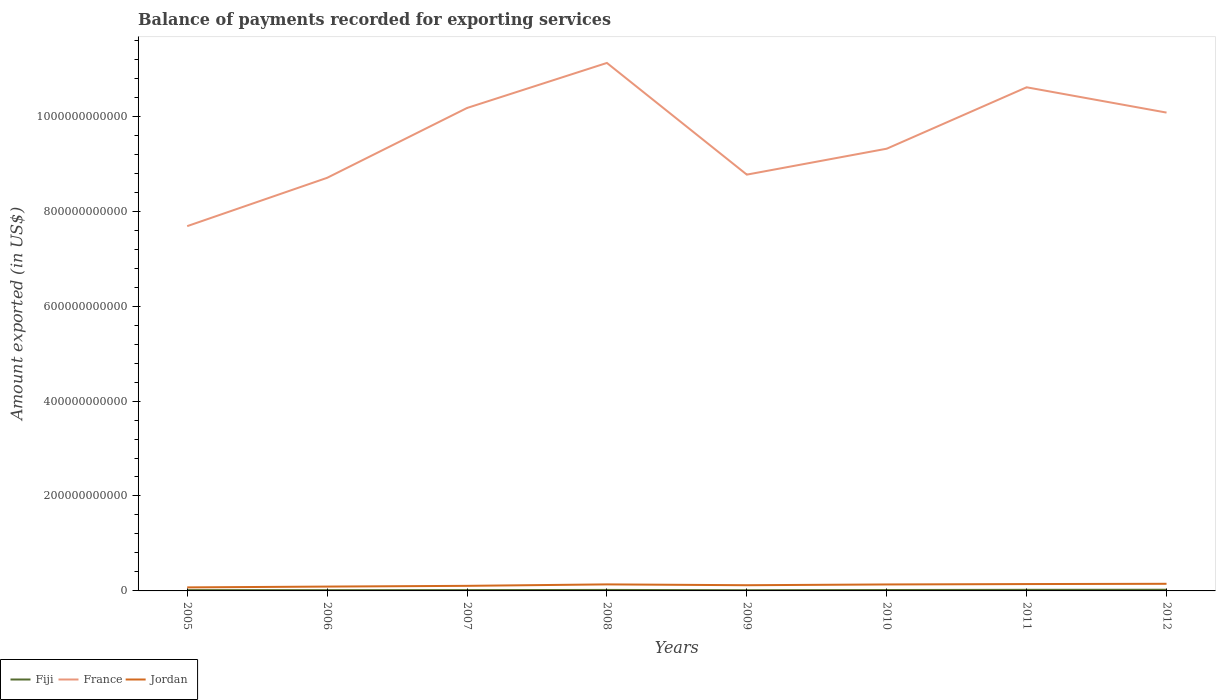How many different coloured lines are there?
Your response must be concise. 3. Does the line corresponding to Fiji intersect with the line corresponding to France?
Your response must be concise. No. Is the number of lines equal to the number of legend labels?
Keep it short and to the point. Yes. Across all years, what is the maximum amount exported in Fiji?
Offer a terse response. 1.48e+09. What is the total amount exported in France in the graph?
Ensure brevity in your answer.  -9.49e+1. What is the difference between the highest and the second highest amount exported in France?
Provide a succinct answer. 3.44e+11. How many lines are there?
Offer a terse response. 3. How many years are there in the graph?
Your answer should be very brief. 8. What is the difference between two consecutive major ticks on the Y-axis?
Give a very brief answer. 2.00e+11. Are the values on the major ticks of Y-axis written in scientific E-notation?
Your response must be concise. No. Does the graph contain any zero values?
Ensure brevity in your answer.  No. Does the graph contain grids?
Offer a terse response. No. Where does the legend appear in the graph?
Your response must be concise. Bottom left. How many legend labels are there?
Your answer should be very brief. 3. What is the title of the graph?
Provide a short and direct response. Balance of payments recorded for exporting services. What is the label or title of the Y-axis?
Make the answer very short. Amount exported (in US$). What is the Amount exported (in US$) in Fiji in 2005?
Make the answer very short. 1.69e+09. What is the Amount exported (in US$) of France in 2005?
Ensure brevity in your answer.  7.68e+11. What is the Amount exported (in US$) in Jordan in 2005?
Provide a succinct answer. 7.43e+09. What is the Amount exported (in US$) in Fiji in 2006?
Give a very brief answer. 1.61e+09. What is the Amount exported (in US$) in France in 2006?
Your response must be concise. 8.70e+11. What is the Amount exported (in US$) of Jordan in 2006?
Offer a terse response. 9.14e+09. What is the Amount exported (in US$) of Fiji in 2007?
Make the answer very short. 1.72e+09. What is the Amount exported (in US$) in France in 2007?
Your response must be concise. 1.02e+12. What is the Amount exported (in US$) in Jordan in 2007?
Provide a succinct answer. 1.07e+1. What is the Amount exported (in US$) in Fiji in 2008?
Offer a very short reply. 2.09e+09. What is the Amount exported (in US$) of France in 2008?
Your response must be concise. 1.11e+12. What is the Amount exported (in US$) in Jordan in 2008?
Provide a succinct answer. 1.38e+1. What is the Amount exported (in US$) of Fiji in 2009?
Offer a terse response. 1.48e+09. What is the Amount exported (in US$) in France in 2009?
Your answer should be compact. 8.77e+11. What is the Amount exported (in US$) in Jordan in 2009?
Your answer should be compact. 1.20e+1. What is the Amount exported (in US$) of Fiji in 2010?
Ensure brevity in your answer.  1.90e+09. What is the Amount exported (in US$) in France in 2010?
Your response must be concise. 9.32e+11. What is the Amount exported (in US$) of Jordan in 2010?
Provide a short and direct response. 1.36e+1. What is the Amount exported (in US$) in Fiji in 2011?
Offer a very short reply. 2.33e+09. What is the Amount exported (in US$) of France in 2011?
Your answer should be compact. 1.06e+12. What is the Amount exported (in US$) of Jordan in 2011?
Provide a short and direct response. 1.45e+1. What is the Amount exported (in US$) in Fiji in 2012?
Your response must be concise. 2.51e+09. What is the Amount exported (in US$) in France in 2012?
Your answer should be compact. 1.01e+12. What is the Amount exported (in US$) in Jordan in 2012?
Offer a terse response. 1.50e+1. Across all years, what is the maximum Amount exported (in US$) of Fiji?
Your response must be concise. 2.51e+09. Across all years, what is the maximum Amount exported (in US$) of France?
Provide a short and direct response. 1.11e+12. Across all years, what is the maximum Amount exported (in US$) in Jordan?
Your response must be concise. 1.50e+1. Across all years, what is the minimum Amount exported (in US$) in Fiji?
Offer a very short reply. 1.48e+09. Across all years, what is the minimum Amount exported (in US$) in France?
Make the answer very short. 7.68e+11. Across all years, what is the minimum Amount exported (in US$) of Jordan?
Provide a short and direct response. 7.43e+09. What is the total Amount exported (in US$) in Fiji in the graph?
Give a very brief answer. 1.53e+1. What is the total Amount exported (in US$) in France in the graph?
Your answer should be compact. 7.65e+12. What is the total Amount exported (in US$) in Jordan in the graph?
Offer a terse response. 9.61e+1. What is the difference between the Amount exported (in US$) in Fiji in 2005 and that in 2006?
Your answer should be very brief. 8.41e+07. What is the difference between the Amount exported (in US$) of France in 2005 and that in 2006?
Offer a terse response. -1.02e+11. What is the difference between the Amount exported (in US$) in Jordan in 2005 and that in 2006?
Your response must be concise. -1.72e+09. What is the difference between the Amount exported (in US$) of Fiji in 2005 and that in 2007?
Make the answer very short. -2.36e+07. What is the difference between the Amount exported (in US$) in France in 2005 and that in 2007?
Ensure brevity in your answer.  -2.49e+11. What is the difference between the Amount exported (in US$) of Jordan in 2005 and that in 2007?
Offer a terse response. -3.26e+09. What is the difference between the Amount exported (in US$) in Fiji in 2005 and that in 2008?
Ensure brevity in your answer.  -3.97e+08. What is the difference between the Amount exported (in US$) of France in 2005 and that in 2008?
Provide a succinct answer. -3.44e+11. What is the difference between the Amount exported (in US$) of Jordan in 2005 and that in 2008?
Ensure brevity in your answer.  -6.32e+09. What is the difference between the Amount exported (in US$) of Fiji in 2005 and that in 2009?
Your response must be concise. 2.10e+08. What is the difference between the Amount exported (in US$) of France in 2005 and that in 2009?
Offer a very short reply. -1.09e+11. What is the difference between the Amount exported (in US$) in Jordan in 2005 and that in 2009?
Your answer should be compact. -4.60e+09. What is the difference between the Amount exported (in US$) in Fiji in 2005 and that in 2010?
Keep it short and to the point. -2.05e+08. What is the difference between the Amount exported (in US$) of France in 2005 and that in 2010?
Your response must be concise. -1.63e+11. What is the difference between the Amount exported (in US$) of Jordan in 2005 and that in 2010?
Provide a succinct answer. -6.21e+09. What is the difference between the Amount exported (in US$) in Fiji in 2005 and that in 2011?
Your answer should be compact. -6.37e+08. What is the difference between the Amount exported (in US$) of France in 2005 and that in 2011?
Your answer should be compact. -2.93e+11. What is the difference between the Amount exported (in US$) in Jordan in 2005 and that in 2011?
Provide a succinct answer. -7.03e+09. What is the difference between the Amount exported (in US$) of Fiji in 2005 and that in 2012?
Offer a terse response. -8.17e+08. What is the difference between the Amount exported (in US$) of France in 2005 and that in 2012?
Offer a terse response. -2.39e+11. What is the difference between the Amount exported (in US$) in Jordan in 2005 and that in 2012?
Your response must be concise. -7.57e+09. What is the difference between the Amount exported (in US$) of Fiji in 2006 and that in 2007?
Provide a succinct answer. -1.08e+08. What is the difference between the Amount exported (in US$) of France in 2006 and that in 2007?
Provide a succinct answer. -1.47e+11. What is the difference between the Amount exported (in US$) of Jordan in 2006 and that in 2007?
Offer a very short reply. -1.54e+09. What is the difference between the Amount exported (in US$) of Fiji in 2006 and that in 2008?
Give a very brief answer. -4.81e+08. What is the difference between the Amount exported (in US$) in France in 2006 and that in 2008?
Offer a terse response. -2.42e+11. What is the difference between the Amount exported (in US$) of Jordan in 2006 and that in 2008?
Give a very brief answer. -4.61e+09. What is the difference between the Amount exported (in US$) in Fiji in 2006 and that in 2009?
Offer a terse response. 1.26e+08. What is the difference between the Amount exported (in US$) in France in 2006 and that in 2009?
Offer a terse response. -6.76e+09. What is the difference between the Amount exported (in US$) in Jordan in 2006 and that in 2009?
Ensure brevity in your answer.  -2.88e+09. What is the difference between the Amount exported (in US$) in Fiji in 2006 and that in 2010?
Provide a short and direct response. -2.89e+08. What is the difference between the Amount exported (in US$) in France in 2006 and that in 2010?
Provide a succinct answer. -6.14e+1. What is the difference between the Amount exported (in US$) of Jordan in 2006 and that in 2010?
Your answer should be very brief. -4.50e+09. What is the difference between the Amount exported (in US$) in Fiji in 2006 and that in 2011?
Your answer should be compact. -7.21e+08. What is the difference between the Amount exported (in US$) of France in 2006 and that in 2011?
Make the answer very short. -1.91e+11. What is the difference between the Amount exported (in US$) in Jordan in 2006 and that in 2011?
Your response must be concise. -5.31e+09. What is the difference between the Amount exported (in US$) of Fiji in 2006 and that in 2012?
Keep it short and to the point. -9.01e+08. What is the difference between the Amount exported (in US$) in France in 2006 and that in 2012?
Offer a very short reply. -1.37e+11. What is the difference between the Amount exported (in US$) in Jordan in 2006 and that in 2012?
Keep it short and to the point. -5.85e+09. What is the difference between the Amount exported (in US$) of Fiji in 2007 and that in 2008?
Your response must be concise. -3.73e+08. What is the difference between the Amount exported (in US$) of France in 2007 and that in 2008?
Offer a terse response. -9.49e+1. What is the difference between the Amount exported (in US$) of Jordan in 2007 and that in 2008?
Provide a succinct answer. -3.07e+09. What is the difference between the Amount exported (in US$) of Fiji in 2007 and that in 2009?
Your answer should be very brief. 2.34e+08. What is the difference between the Amount exported (in US$) in France in 2007 and that in 2009?
Offer a very short reply. 1.40e+11. What is the difference between the Amount exported (in US$) of Jordan in 2007 and that in 2009?
Offer a very short reply. -1.34e+09. What is the difference between the Amount exported (in US$) of Fiji in 2007 and that in 2010?
Provide a succinct answer. -1.82e+08. What is the difference between the Amount exported (in US$) of France in 2007 and that in 2010?
Provide a succinct answer. 8.58e+1. What is the difference between the Amount exported (in US$) of Jordan in 2007 and that in 2010?
Keep it short and to the point. -2.96e+09. What is the difference between the Amount exported (in US$) in Fiji in 2007 and that in 2011?
Keep it short and to the point. -6.14e+08. What is the difference between the Amount exported (in US$) in France in 2007 and that in 2011?
Offer a terse response. -4.36e+1. What is the difference between the Amount exported (in US$) of Jordan in 2007 and that in 2011?
Provide a short and direct response. -3.77e+09. What is the difference between the Amount exported (in US$) of Fiji in 2007 and that in 2012?
Your answer should be very brief. -7.94e+08. What is the difference between the Amount exported (in US$) in France in 2007 and that in 2012?
Ensure brevity in your answer.  9.70e+09. What is the difference between the Amount exported (in US$) of Jordan in 2007 and that in 2012?
Give a very brief answer. -4.31e+09. What is the difference between the Amount exported (in US$) in Fiji in 2008 and that in 2009?
Provide a short and direct response. 6.07e+08. What is the difference between the Amount exported (in US$) in France in 2008 and that in 2009?
Your answer should be compact. 2.35e+11. What is the difference between the Amount exported (in US$) in Jordan in 2008 and that in 2009?
Your answer should be compact. 1.73e+09. What is the difference between the Amount exported (in US$) of Fiji in 2008 and that in 2010?
Keep it short and to the point. 1.92e+08. What is the difference between the Amount exported (in US$) of France in 2008 and that in 2010?
Your answer should be compact. 1.81e+11. What is the difference between the Amount exported (in US$) in Jordan in 2008 and that in 2010?
Make the answer very short. 1.12e+08. What is the difference between the Amount exported (in US$) in Fiji in 2008 and that in 2011?
Offer a terse response. -2.40e+08. What is the difference between the Amount exported (in US$) of France in 2008 and that in 2011?
Keep it short and to the point. 5.13e+1. What is the difference between the Amount exported (in US$) in Jordan in 2008 and that in 2011?
Your response must be concise. -7.04e+08. What is the difference between the Amount exported (in US$) in Fiji in 2008 and that in 2012?
Your answer should be very brief. -4.21e+08. What is the difference between the Amount exported (in US$) of France in 2008 and that in 2012?
Provide a succinct answer. 1.05e+11. What is the difference between the Amount exported (in US$) of Jordan in 2008 and that in 2012?
Provide a succinct answer. -1.25e+09. What is the difference between the Amount exported (in US$) of Fiji in 2009 and that in 2010?
Provide a succinct answer. -4.15e+08. What is the difference between the Amount exported (in US$) in France in 2009 and that in 2010?
Your response must be concise. -5.46e+1. What is the difference between the Amount exported (in US$) of Jordan in 2009 and that in 2010?
Offer a terse response. -1.62e+09. What is the difference between the Amount exported (in US$) of Fiji in 2009 and that in 2011?
Your response must be concise. -8.47e+08. What is the difference between the Amount exported (in US$) in France in 2009 and that in 2011?
Give a very brief answer. -1.84e+11. What is the difference between the Amount exported (in US$) in Jordan in 2009 and that in 2011?
Your answer should be compact. -2.43e+09. What is the difference between the Amount exported (in US$) of Fiji in 2009 and that in 2012?
Give a very brief answer. -1.03e+09. What is the difference between the Amount exported (in US$) in France in 2009 and that in 2012?
Offer a terse response. -1.31e+11. What is the difference between the Amount exported (in US$) of Jordan in 2009 and that in 2012?
Make the answer very short. -2.97e+09. What is the difference between the Amount exported (in US$) of Fiji in 2010 and that in 2011?
Ensure brevity in your answer.  -4.32e+08. What is the difference between the Amount exported (in US$) in France in 2010 and that in 2011?
Make the answer very short. -1.29e+11. What is the difference between the Amount exported (in US$) in Jordan in 2010 and that in 2011?
Your answer should be compact. -8.15e+08. What is the difference between the Amount exported (in US$) in Fiji in 2010 and that in 2012?
Provide a short and direct response. -6.12e+08. What is the difference between the Amount exported (in US$) of France in 2010 and that in 2012?
Give a very brief answer. -7.61e+1. What is the difference between the Amount exported (in US$) of Jordan in 2010 and that in 2012?
Keep it short and to the point. -1.36e+09. What is the difference between the Amount exported (in US$) of Fiji in 2011 and that in 2012?
Offer a very short reply. -1.80e+08. What is the difference between the Amount exported (in US$) of France in 2011 and that in 2012?
Give a very brief answer. 5.33e+1. What is the difference between the Amount exported (in US$) in Jordan in 2011 and that in 2012?
Offer a terse response. -5.43e+08. What is the difference between the Amount exported (in US$) in Fiji in 2005 and the Amount exported (in US$) in France in 2006?
Your response must be concise. -8.69e+11. What is the difference between the Amount exported (in US$) in Fiji in 2005 and the Amount exported (in US$) in Jordan in 2006?
Keep it short and to the point. -7.45e+09. What is the difference between the Amount exported (in US$) in France in 2005 and the Amount exported (in US$) in Jordan in 2006?
Your response must be concise. 7.59e+11. What is the difference between the Amount exported (in US$) of Fiji in 2005 and the Amount exported (in US$) of France in 2007?
Make the answer very short. -1.02e+12. What is the difference between the Amount exported (in US$) of Fiji in 2005 and the Amount exported (in US$) of Jordan in 2007?
Ensure brevity in your answer.  -8.99e+09. What is the difference between the Amount exported (in US$) of France in 2005 and the Amount exported (in US$) of Jordan in 2007?
Your answer should be very brief. 7.58e+11. What is the difference between the Amount exported (in US$) in Fiji in 2005 and the Amount exported (in US$) in France in 2008?
Give a very brief answer. -1.11e+12. What is the difference between the Amount exported (in US$) in Fiji in 2005 and the Amount exported (in US$) in Jordan in 2008?
Offer a terse response. -1.21e+1. What is the difference between the Amount exported (in US$) in France in 2005 and the Amount exported (in US$) in Jordan in 2008?
Your answer should be compact. 7.55e+11. What is the difference between the Amount exported (in US$) in Fiji in 2005 and the Amount exported (in US$) in France in 2009?
Offer a very short reply. -8.75e+11. What is the difference between the Amount exported (in US$) in Fiji in 2005 and the Amount exported (in US$) in Jordan in 2009?
Keep it short and to the point. -1.03e+1. What is the difference between the Amount exported (in US$) in France in 2005 and the Amount exported (in US$) in Jordan in 2009?
Keep it short and to the point. 7.56e+11. What is the difference between the Amount exported (in US$) of Fiji in 2005 and the Amount exported (in US$) of France in 2010?
Make the answer very short. -9.30e+11. What is the difference between the Amount exported (in US$) of Fiji in 2005 and the Amount exported (in US$) of Jordan in 2010?
Keep it short and to the point. -1.19e+1. What is the difference between the Amount exported (in US$) of France in 2005 and the Amount exported (in US$) of Jordan in 2010?
Ensure brevity in your answer.  7.55e+11. What is the difference between the Amount exported (in US$) of Fiji in 2005 and the Amount exported (in US$) of France in 2011?
Keep it short and to the point. -1.06e+12. What is the difference between the Amount exported (in US$) of Fiji in 2005 and the Amount exported (in US$) of Jordan in 2011?
Give a very brief answer. -1.28e+1. What is the difference between the Amount exported (in US$) in France in 2005 and the Amount exported (in US$) in Jordan in 2011?
Offer a terse response. 7.54e+11. What is the difference between the Amount exported (in US$) in Fiji in 2005 and the Amount exported (in US$) in France in 2012?
Provide a succinct answer. -1.01e+12. What is the difference between the Amount exported (in US$) of Fiji in 2005 and the Amount exported (in US$) of Jordan in 2012?
Your answer should be very brief. -1.33e+1. What is the difference between the Amount exported (in US$) in France in 2005 and the Amount exported (in US$) in Jordan in 2012?
Ensure brevity in your answer.  7.53e+11. What is the difference between the Amount exported (in US$) in Fiji in 2006 and the Amount exported (in US$) in France in 2007?
Make the answer very short. -1.02e+12. What is the difference between the Amount exported (in US$) of Fiji in 2006 and the Amount exported (in US$) of Jordan in 2007?
Give a very brief answer. -9.07e+09. What is the difference between the Amount exported (in US$) in France in 2006 and the Amount exported (in US$) in Jordan in 2007?
Your answer should be very brief. 8.60e+11. What is the difference between the Amount exported (in US$) of Fiji in 2006 and the Amount exported (in US$) of France in 2008?
Give a very brief answer. -1.11e+12. What is the difference between the Amount exported (in US$) of Fiji in 2006 and the Amount exported (in US$) of Jordan in 2008?
Provide a succinct answer. -1.21e+1. What is the difference between the Amount exported (in US$) of France in 2006 and the Amount exported (in US$) of Jordan in 2008?
Make the answer very short. 8.56e+11. What is the difference between the Amount exported (in US$) in Fiji in 2006 and the Amount exported (in US$) in France in 2009?
Provide a short and direct response. -8.75e+11. What is the difference between the Amount exported (in US$) in Fiji in 2006 and the Amount exported (in US$) in Jordan in 2009?
Give a very brief answer. -1.04e+1. What is the difference between the Amount exported (in US$) of France in 2006 and the Amount exported (in US$) of Jordan in 2009?
Keep it short and to the point. 8.58e+11. What is the difference between the Amount exported (in US$) in Fiji in 2006 and the Amount exported (in US$) in France in 2010?
Offer a very short reply. -9.30e+11. What is the difference between the Amount exported (in US$) in Fiji in 2006 and the Amount exported (in US$) in Jordan in 2010?
Your answer should be compact. -1.20e+1. What is the difference between the Amount exported (in US$) in France in 2006 and the Amount exported (in US$) in Jordan in 2010?
Make the answer very short. 8.57e+11. What is the difference between the Amount exported (in US$) in Fiji in 2006 and the Amount exported (in US$) in France in 2011?
Your response must be concise. -1.06e+12. What is the difference between the Amount exported (in US$) of Fiji in 2006 and the Amount exported (in US$) of Jordan in 2011?
Give a very brief answer. -1.28e+1. What is the difference between the Amount exported (in US$) of France in 2006 and the Amount exported (in US$) of Jordan in 2011?
Make the answer very short. 8.56e+11. What is the difference between the Amount exported (in US$) of Fiji in 2006 and the Amount exported (in US$) of France in 2012?
Your answer should be compact. -1.01e+12. What is the difference between the Amount exported (in US$) of Fiji in 2006 and the Amount exported (in US$) of Jordan in 2012?
Give a very brief answer. -1.34e+1. What is the difference between the Amount exported (in US$) in France in 2006 and the Amount exported (in US$) in Jordan in 2012?
Provide a succinct answer. 8.55e+11. What is the difference between the Amount exported (in US$) of Fiji in 2007 and the Amount exported (in US$) of France in 2008?
Your answer should be very brief. -1.11e+12. What is the difference between the Amount exported (in US$) of Fiji in 2007 and the Amount exported (in US$) of Jordan in 2008?
Keep it short and to the point. -1.20e+1. What is the difference between the Amount exported (in US$) in France in 2007 and the Amount exported (in US$) in Jordan in 2008?
Offer a very short reply. 1.00e+12. What is the difference between the Amount exported (in US$) of Fiji in 2007 and the Amount exported (in US$) of France in 2009?
Ensure brevity in your answer.  -8.75e+11. What is the difference between the Amount exported (in US$) of Fiji in 2007 and the Amount exported (in US$) of Jordan in 2009?
Give a very brief answer. -1.03e+1. What is the difference between the Amount exported (in US$) of France in 2007 and the Amount exported (in US$) of Jordan in 2009?
Provide a succinct answer. 1.01e+12. What is the difference between the Amount exported (in US$) of Fiji in 2007 and the Amount exported (in US$) of France in 2010?
Your response must be concise. -9.30e+11. What is the difference between the Amount exported (in US$) of Fiji in 2007 and the Amount exported (in US$) of Jordan in 2010?
Your response must be concise. -1.19e+1. What is the difference between the Amount exported (in US$) in France in 2007 and the Amount exported (in US$) in Jordan in 2010?
Your answer should be compact. 1.00e+12. What is the difference between the Amount exported (in US$) in Fiji in 2007 and the Amount exported (in US$) in France in 2011?
Give a very brief answer. -1.06e+12. What is the difference between the Amount exported (in US$) in Fiji in 2007 and the Amount exported (in US$) in Jordan in 2011?
Offer a terse response. -1.27e+1. What is the difference between the Amount exported (in US$) in France in 2007 and the Amount exported (in US$) in Jordan in 2011?
Keep it short and to the point. 1.00e+12. What is the difference between the Amount exported (in US$) in Fiji in 2007 and the Amount exported (in US$) in France in 2012?
Give a very brief answer. -1.01e+12. What is the difference between the Amount exported (in US$) of Fiji in 2007 and the Amount exported (in US$) of Jordan in 2012?
Offer a very short reply. -1.33e+1. What is the difference between the Amount exported (in US$) of France in 2007 and the Amount exported (in US$) of Jordan in 2012?
Ensure brevity in your answer.  1.00e+12. What is the difference between the Amount exported (in US$) of Fiji in 2008 and the Amount exported (in US$) of France in 2009?
Offer a very short reply. -8.75e+11. What is the difference between the Amount exported (in US$) of Fiji in 2008 and the Amount exported (in US$) of Jordan in 2009?
Your answer should be compact. -9.93e+09. What is the difference between the Amount exported (in US$) of France in 2008 and the Amount exported (in US$) of Jordan in 2009?
Provide a short and direct response. 1.10e+12. What is the difference between the Amount exported (in US$) of Fiji in 2008 and the Amount exported (in US$) of France in 2010?
Ensure brevity in your answer.  -9.29e+11. What is the difference between the Amount exported (in US$) in Fiji in 2008 and the Amount exported (in US$) in Jordan in 2010?
Provide a short and direct response. -1.15e+1. What is the difference between the Amount exported (in US$) in France in 2008 and the Amount exported (in US$) in Jordan in 2010?
Your answer should be very brief. 1.10e+12. What is the difference between the Amount exported (in US$) in Fiji in 2008 and the Amount exported (in US$) in France in 2011?
Ensure brevity in your answer.  -1.06e+12. What is the difference between the Amount exported (in US$) of Fiji in 2008 and the Amount exported (in US$) of Jordan in 2011?
Offer a very short reply. -1.24e+1. What is the difference between the Amount exported (in US$) of France in 2008 and the Amount exported (in US$) of Jordan in 2011?
Keep it short and to the point. 1.10e+12. What is the difference between the Amount exported (in US$) of Fiji in 2008 and the Amount exported (in US$) of France in 2012?
Ensure brevity in your answer.  -1.01e+12. What is the difference between the Amount exported (in US$) in Fiji in 2008 and the Amount exported (in US$) in Jordan in 2012?
Keep it short and to the point. -1.29e+1. What is the difference between the Amount exported (in US$) of France in 2008 and the Amount exported (in US$) of Jordan in 2012?
Your answer should be very brief. 1.10e+12. What is the difference between the Amount exported (in US$) in Fiji in 2009 and the Amount exported (in US$) in France in 2010?
Offer a very short reply. -9.30e+11. What is the difference between the Amount exported (in US$) of Fiji in 2009 and the Amount exported (in US$) of Jordan in 2010?
Your answer should be very brief. -1.22e+1. What is the difference between the Amount exported (in US$) in France in 2009 and the Amount exported (in US$) in Jordan in 2010?
Your answer should be very brief. 8.63e+11. What is the difference between the Amount exported (in US$) in Fiji in 2009 and the Amount exported (in US$) in France in 2011?
Your answer should be very brief. -1.06e+12. What is the difference between the Amount exported (in US$) of Fiji in 2009 and the Amount exported (in US$) of Jordan in 2011?
Offer a terse response. -1.30e+1. What is the difference between the Amount exported (in US$) of France in 2009 and the Amount exported (in US$) of Jordan in 2011?
Your response must be concise. 8.63e+11. What is the difference between the Amount exported (in US$) in Fiji in 2009 and the Amount exported (in US$) in France in 2012?
Ensure brevity in your answer.  -1.01e+12. What is the difference between the Amount exported (in US$) of Fiji in 2009 and the Amount exported (in US$) of Jordan in 2012?
Your answer should be very brief. -1.35e+1. What is the difference between the Amount exported (in US$) of France in 2009 and the Amount exported (in US$) of Jordan in 2012?
Give a very brief answer. 8.62e+11. What is the difference between the Amount exported (in US$) of Fiji in 2010 and the Amount exported (in US$) of France in 2011?
Make the answer very short. -1.06e+12. What is the difference between the Amount exported (in US$) in Fiji in 2010 and the Amount exported (in US$) in Jordan in 2011?
Keep it short and to the point. -1.26e+1. What is the difference between the Amount exported (in US$) of France in 2010 and the Amount exported (in US$) of Jordan in 2011?
Provide a short and direct response. 9.17e+11. What is the difference between the Amount exported (in US$) of Fiji in 2010 and the Amount exported (in US$) of France in 2012?
Your answer should be compact. -1.01e+12. What is the difference between the Amount exported (in US$) of Fiji in 2010 and the Amount exported (in US$) of Jordan in 2012?
Ensure brevity in your answer.  -1.31e+1. What is the difference between the Amount exported (in US$) in France in 2010 and the Amount exported (in US$) in Jordan in 2012?
Offer a very short reply. 9.17e+11. What is the difference between the Amount exported (in US$) of Fiji in 2011 and the Amount exported (in US$) of France in 2012?
Provide a short and direct response. -1.01e+12. What is the difference between the Amount exported (in US$) of Fiji in 2011 and the Amount exported (in US$) of Jordan in 2012?
Offer a very short reply. -1.27e+1. What is the difference between the Amount exported (in US$) of France in 2011 and the Amount exported (in US$) of Jordan in 2012?
Provide a succinct answer. 1.05e+12. What is the average Amount exported (in US$) in Fiji per year?
Your answer should be very brief. 1.92e+09. What is the average Amount exported (in US$) of France per year?
Provide a succinct answer. 9.56e+11. What is the average Amount exported (in US$) in Jordan per year?
Your answer should be very brief. 1.20e+1. In the year 2005, what is the difference between the Amount exported (in US$) of Fiji and Amount exported (in US$) of France?
Offer a terse response. -7.67e+11. In the year 2005, what is the difference between the Amount exported (in US$) of Fiji and Amount exported (in US$) of Jordan?
Offer a terse response. -5.73e+09. In the year 2005, what is the difference between the Amount exported (in US$) of France and Amount exported (in US$) of Jordan?
Ensure brevity in your answer.  7.61e+11. In the year 2006, what is the difference between the Amount exported (in US$) in Fiji and Amount exported (in US$) in France?
Your response must be concise. -8.69e+11. In the year 2006, what is the difference between the Amount exported (in US$) in Fiji and Amount exported (in US$) in Jordan?
Make the answer very short. -7.53e+09. In the year 2006, what is the difference between the Amount exported (in US$) in France and Amount exported (in US$) in Jordan?
Provide a succinct answer. 8.61e+11. In the year 2007, what is the difference between the Amount exported (in US$) in Fiji and Amount exported (in US$) in France?
Your answer should be very brief. -1.02e+12. In the year 2007, what is the difference between the Amount exported (in US$) in Fiji and Amount exported (in US$) in Jordan?
Keep it short and to the point. -8.97e+09. In the year 2007, what is the difference between the Amount exported (in US$) of France and Amount exported (in US$) of Jordan?
Your answer should be compact. 1.01e+12. In the year 2008, what is the difference between the Amount exported (in US$) in Fiji and Amount exported (in US$) in France?
Offer a terse response. -1.11e+12. In the year 2008, what is the difference between the Amount exported (in US$) in Fiji and Amount exported (in US$) in Jordan?
Your answer should be very brief. -1.17e+1. In the year 2008, what is the difference between the Amount exported (in US$) in France and Amount exported (in US$) in Jordan?
Offer a very short reply. 1.10e+12. In the year 2009, what is the difference between the Amount exported (in US$) of Fiji and Amount exported (in US$) of France?
Offer a terse response. -8.76e+11. In the year 2009, what is the difference between the Amount exported (in US$) in Fiji and Amount exported (in US$) in Jordan?
Offer a terse response. -1.05e+1. In the year 2009, what is the difference between the Amount exported (in US$) in France and Amount exported (in US$) in Jordan?
Your answer should be compact. 8.65e+11. In the year 2010, what is the difference between the Amount exported (in US$) in Fiji and Amount exported (in US$) in France?
Offer a very short reply. -9.30e+11. In the year 2010, what is the difference between the Amount exported (in US$) of Fiji and Amount exported (in US$) of Jordan?
Your answer should be compact. -1.17e+1. In the year 2010, what is the difference between the Amount exported (in US$) in France and Amount exported (in US$) in Jordan?
Your response must be concise. 9.18e+11. In the year 2011, what is the difference between the Amount exported (in US$) of Fiji and Amount exported (in US$) of France?
Provide a short and direct response. -1.06e+12. In the year 2011, what is the difference between the Amount exported (in US$) of Fiji and Amount exported (in US$) of Jordan?
Your response must be concise. -1.21e+1. In the year 2011, what is the difference between the Amount exported (in US$) in France and Amount exported (in US$) in Jordan?
Give a very brief answer. 1.05e+12. In the year 2012, what is the difference between the Amount exported (in US$) in Fiji and Amount exported (in US$) in France?
Offer a terse response. -1.01e+12. In the year 2012, what is the difference between the Amount exported (in US$) of Fiji and Amount exported (in US$) of Jordan?
Ensure brevity in your answer.  -1.25e+1. In the year 2012, what is the difference between the Amount exported (in US$) of France and Amount exported (in US$) of Jordan?
Offer a very short reply. 9.93e+11. What is the ratio of the Amount exported (in US$) in Fiji in 2005 to that in 2006?
Your response must be concise. 1.05. What is the ratio of the Amount exported (in US$) of France in 2005 to that in 2006?
Offer a terse response. 0.88. What is the ratio of the Amount exported (in US$) of Jordan in 2005 to that in 2006?
Make the answer very short. 0.81. What is the ratio of the Amount exported (in US$) of Fiji in 2005 to that in 2007?
Offer a terse response. 0.99. What is the ratio of the Amount exported (in US$) of France in 2005 to that in 2007?
Give a very brief answer. 0.76. What is the ratio of the Amount exported (in US$) of Jordan in 2005 to that in 2007?
Your answer should be compact. 0.7. What is the ratio of the Amount exported (in US$) in Fiji in 2005 to that in 2008?
Make the answer very short. 0.81. What is the ratio of the Amount exported (in US$) of France in 2005 to that in 2008?
Give a very brief answer. 0.69. What is the ratio of the Amount exported (in US$) in Jordan in 2005 to that in 2008?
Give a very brief answer. 0.54. What is the ratio of the Amount exported (in US$) in Fiji in 2005 to that in 2009?
Give a very brief answer. 1.14. What is the ratio of the Amount exported (in US$) of France in 2005 to that in 2009?
Keep it short and to the point. 0.88. What is the ratio of the Amount exported (in US$) of Jordan in 2005 to that in 2009?
Provide a succinct answer. 0.62. What is the ratio of the Amount exported (in US$) in Fiji in 2005 to that in 2010?
Offer a terse response. 0.89. What is the ratio of the Amount exported (in US$) of France in 2005 to that in 2010?
Provide a short and direct response. 0.82. What is the ratio of the Amount exported (in US$) of Jordan in 2005 to that in 2010?
Ensure brevity in your answer.  0.54. What is the ratio of the Amount exported (in US$) of Fiji in 2005 to that in 2011?
Keep it short and to the point. 0.73. What is the ratio of the Amount exported (in US$) in France in 2005 to that in 2011?
Provide a succinct answer. 0.72. What is the ratio of the Amount exported (in US$) in Jordan in 2005 to that in 2011?
Provide a short and direct response. 0.51. What is the ratio of the Amount exported (in US$) in Fiji in 2005 to that in 2012?
Ensure brevity in your answer.  0.67. What is the ratio of the Amount exported (in US$) in France in 2005 to that in 2012?
Provide a short and direct response. 0.76. What is the ratio of the Amount exported (in US$) of Jordan in 2005 to that in 2012?
Offer a very short reply. 0.5. What is the ratio of the Amount exported (in US$) of Fiji in 2006 to that in 2007?
Provide a short and direct response. 0.94. What is the ratio of the Amount exported (in US$) in France in 2006 to that in 2007?
Ensure brevity in your answer.  0.86. What is the ratio of the Amount exported (in US$) in Jordan in 2006 to that in 2007?
Make the answer very short. 0.86. What is the ratio of the Amount exported (in US$) of Fiji in 2006 to that in 2008?
Keep it short and to the point. 0.77. What is the ratio of the Amount exported (in US$) in France in 2006 to that in 2008?
Make the answer very short. 0.78. What is the ratio of the Amount exported (in US$) in Jordan in 2006 to that in 2008?
Keep it short and to the point. 0.67. What is the ratio of the Amount exported (in US$) in Fiji in 2006 to that in 2009?
Your answer should be compact. 1.09. What is the ratio of the Amount exported (in US$) of Jordan in 2006 to that in 2009?
Give a very brief answer. 0.76. What is the ratio of the Amount exported (in US$) of Fiji in 2006 to that in 2010?
Your response must be concise. 0.85. What is the ratio of the Amount exported (in US$) in France in 2006 to that in 2010?
Ensure brevity in your answer.  0.93. What is the ratio of the Amount exported (in US$) of Jordan in 2006 to that in 2010?
Offer a terse response. 0.67. What is the ratio of the Amount exported (in US$) of Fiji in 2006 to that in 2011?
Your answer should be very brief. 0.69. What is the ratio of the Amount exported (in US$) of France in 2006 to that in 2011?
Make the answer very short. 0.82. What is the ratio of the Amount exported (in US$) of Jordan in 2006 to that in 2011?
Make the answer very short. 0.63. What is the ratio of the Amount exported (in US$) of Fiji in 2006 to that in 2012?
Your response must be concise. 0.64. What is the ratio of the Amount exported (in US$) of France in 2006 to that in 2012?
Ensure brevity in your answer.  0.86. What is the ratio of the Amount exported (in US$) in Jordan in 2006 to that in 2012?
Ensure brevity in your answer.  0.61. What is the ratio of the Amount exported (in US$) in Fiji in 2007 to that in 2008?
Offer a terse response. 0.82. What is the ratio of the Amount exported (in US$) of France in 2007 to that in 2008?
Your answer should be compact. 0.91. What is the ratio of the Amount exported (in US$) in Jordan in 2007 to that in 2008?
Offer a terse response. 0.78. What is the ratio of the Amount exported (in US$) in Fiji in 2007 to that in 2009?
Provide a short and direct response. 1.16. What is the ratio of the Amount exported (in US$) of France in 2007 to that in 2009?
Provide a short and direct response. 1.16. What is the ratio of the Amount exported (in US$) of Jordan in 2007 to that in 2009?
Offer a terse response. 0.89. What is the ratio of the Amount exported (in US$) in Fiji in 2007 to that in 2010?
Offer a very short reply. 0.9. What is the ratio of the Amount exported (in US$) in France in 2007 to that in 2010?
Your answer should be compact. 1.09. What is the ratio of the Amount exported (in US$) in Jordan in 2007 to that in 2010?
Your answer should be compact. 0.78. What is the ratio of the Amount exported (in US$) in Fiji in 2007 to that in 2011?
Give a very brief answer. 0.74. What is the ratio of the Amount exported (in US$) of France in 2007 to that in 2011?
Ensure brevity in your answer.  0.96. What is the ratio of the Amount exported (in US$) of Jordan in 2007 to that in 2011?
Ensure brevity in your answer.  0.74. What is the ratio of the Amount exported (in US$) of Fiji in 2007 to that in 2012?
Offer a very short reply. 0.68. What is the ratio of the Amount exported (in US$) of France in 2007 to that in 2012?
Keep it short and to the point. 1.01. What is the ratio of the Amount exported (in US$) of Jordan in 2007 to that in 2012?
Provide a short and direct response. 0.71. What is the ratio of the Amount exported (in US$) in Fiji in 2008 to that in 2009?
Give a very brief answer. 1.41. What is the ratio of the Amount exported (in US$) in France in 2008 to that in 2009?
Give a very brief answer. 1.27. What is the ratio of the Amount exported (in US$) of Jordan in 2008 to that in 2009?
Make the answer very short. 1.14. What is the ratio of the Amount exported (in US$) in Fiji in 2008 to that in 2010?
Give a very brief answer. 1.1. What is the ratio of the Amount exported (in US$) in France in 2008 to that in 2010?
Give a very brief answer. 1.19. What is the ratio of the Amount exported (in US$) of Jordan in 2008 to that in 2010?
Offer a terse response. 1.01. What is the ratio of the Amount exported (in US$) in Fiji in 2008 to that in 2011?
Give a very brief answer. 0.9. What is the ratio of the Amount exported (in US$) of France in 2008 to that in 2011?
Your response must be concise. 1.05. What is the ratio of the Amount exported (in US$) of Jordan in 2008 to that in 2011?
Keep it short and to the point. 0.95. What is the ratio of the Amount exported (in US$) of Fiji in 2008 to that in 2012?
Ensure brevity in your answer.  0.83. What is the ratio of the Amount exported (in US$) of France in 2008 to that in 2012?
Your answer should be compact. 1.1. What is the ratio of the Amount exported (in US$) of Jordan in 2008 to that in 2012?
Ensure brevity in your answer.  0.92. What is the ratio of the Amount exported (in US$) of Fiji in 2009 to that in 2010?
Make the answer very short. 0.78. What is the ratio of the Amount exported (in US$) of France in 2009 to that in 2010?
Provide a succinct answer. 0.94. What is the ratio of the Amount exported (in US$) in Jordan in 2009 to that in 2010?
Your answer should be very brief. 0.88. What is the ratio of the Amount exported (in US$) in Fiji in 2009 to that in 2011?
Keep it short and to the point. 0.64. What is the ratio of the Amount exported (in US$) in France in 2009 to that in 2011?
Offer a terse response. 0.83. What is the ratio of the Amount exported (in US$) in Jordan in 2009 to that in 2011?
Provide a short and direct response. 0.83. What is the ratio of the Amount exported (in US$) in Fiji in 2009 to that in 2012?
Provide a succinct answer. 0.59. What is the ratio of the Amount exported (in US$) in France in 2009 to that in 2012?
Make the answer very short. 0.87. What is the ratio of the Amount exported (in US$) of Jordan in 2009 to that in 2012?
Your answer should be compact. 0.8. What is the ratio of the Amount exported (in US$) of Fiji in 2010 to that in 2011?
Offer a very short reply. 0.81. What is the ratio of the Amount exported (in US$) in France in 2010 to that in 2011?
Give a very brief answer. 0.88. What is the ratio of the Amount exported (in US$) in Jordan in 2010 to that in 2011?
Provide a short and direct response. 0.94. What is the ratio of the Amount exported (in US$) of Fiji in 2010 to that in 2012?
Your answer should be compact. 0.76. What is the ratio of the Amount exported (in US$) of France in 2010 to that in 2012?
Give a very brief answer. 0.92. What is the ratio of the Amount exported (in US$) of Jordan in 2010 to that in 2012?
Offer a terse response. 0.91. What is the ratio of the Amount exported (in US$) of Fiji in 2011 to that in 2012?
Offer a terse response. 0.93. What is the ratio of the Amount exported (in US$) of France in 2011 to that in 2012?
Provide a short and direct response. 1.05. What is the ratio of the Amount exported (in US$) of Jordan in 2011 to that in 2012?
Provide a short and direct response. 0.96. What is the difference between the highest and the second highest Amount exported (in US$) in Fiji?
Your answer should be compact. 1.80e+08. What is the difference between the highest and the second highest Amount exported (in US$) in France?
Give a very brief answer. 5.13e+1. What is the difference between the highest and the second highest Amount exported (in US$) in Jordan?
Ensure brevity in your answer.  5.43e+08. What is the difference between the highest and the lowest Amount exported (in US$) of Fiji?
Give a very brief answer. 1.03e+09. What is the difference between the highest and the lowest Amount exported (in US$) of France?
Keep it short and to the point. 3.44e+11. What is the difference between the highest and the lowest Amount exported (in US$) of Jordan?
Your answer should be compact. 7.57e+09. 